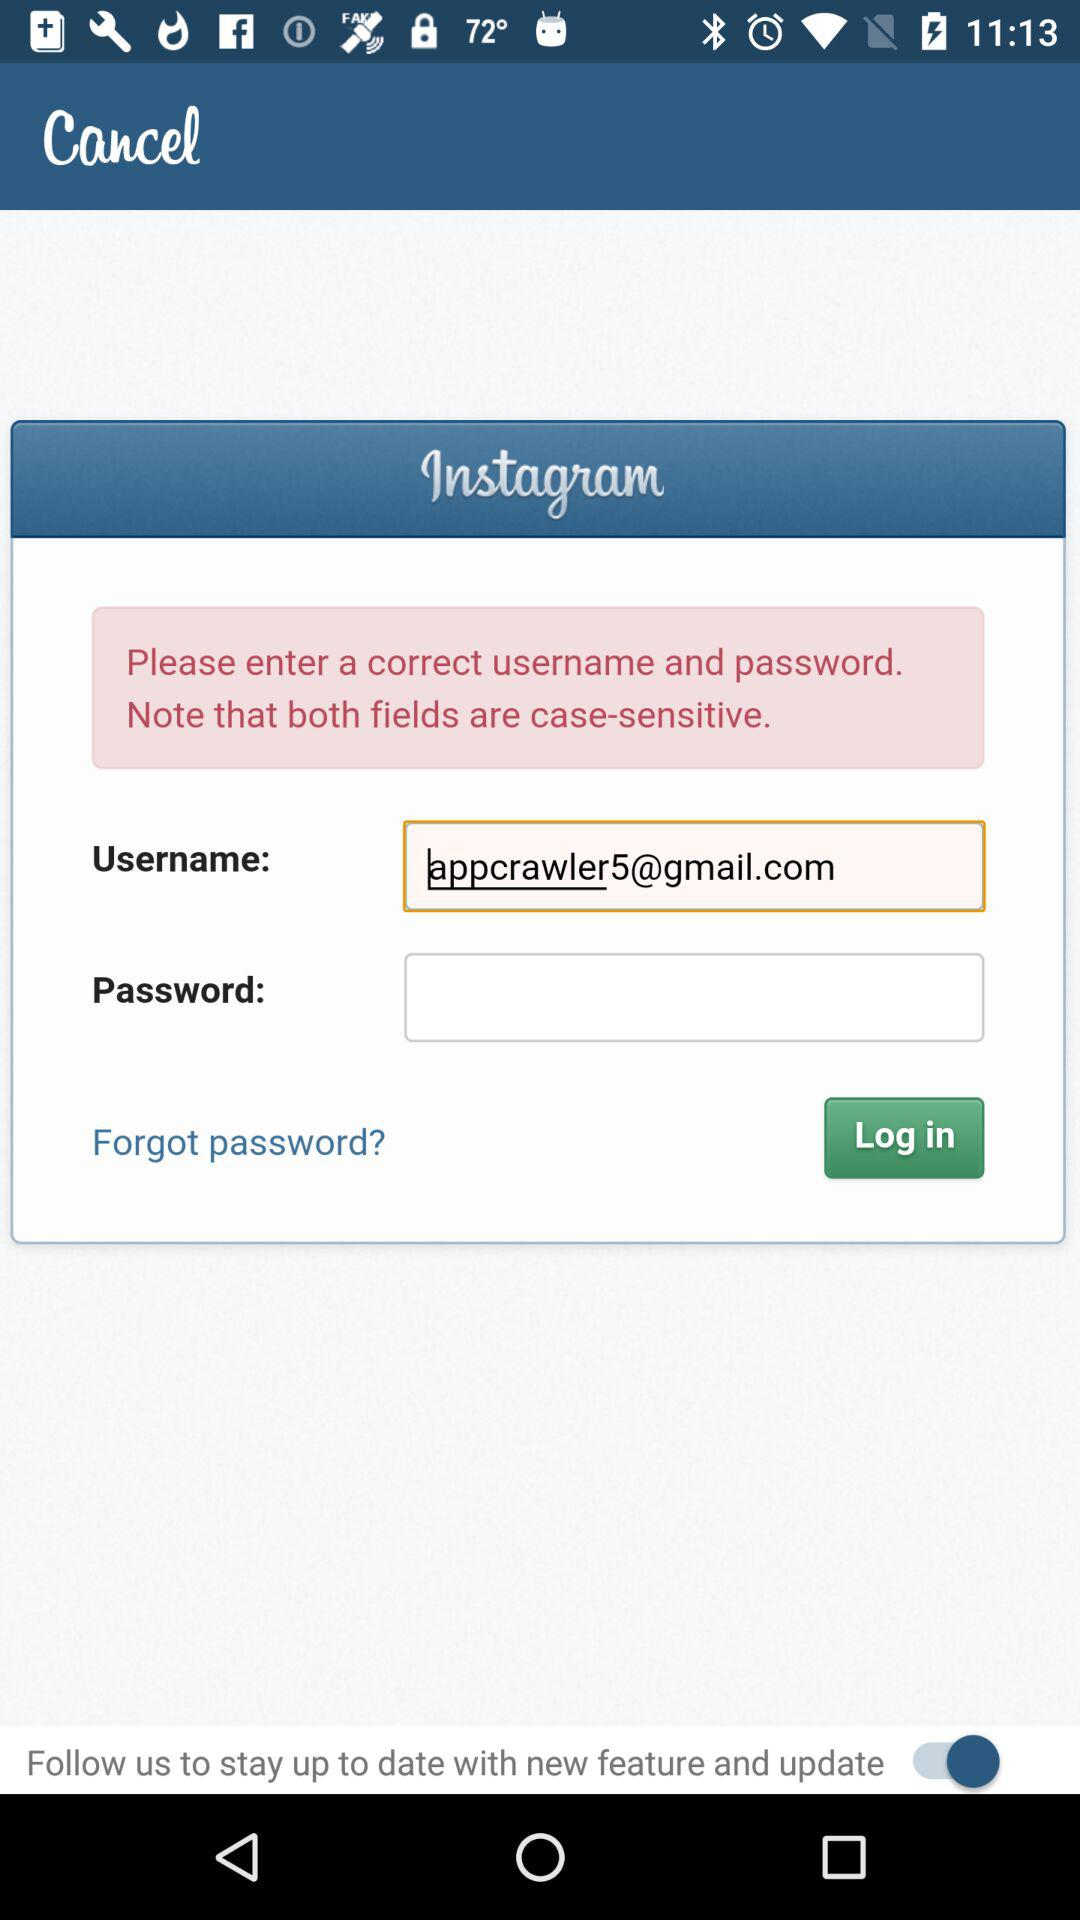What is the status of the "Follow us to stay up to date with new feature and update"? The status is "on". 